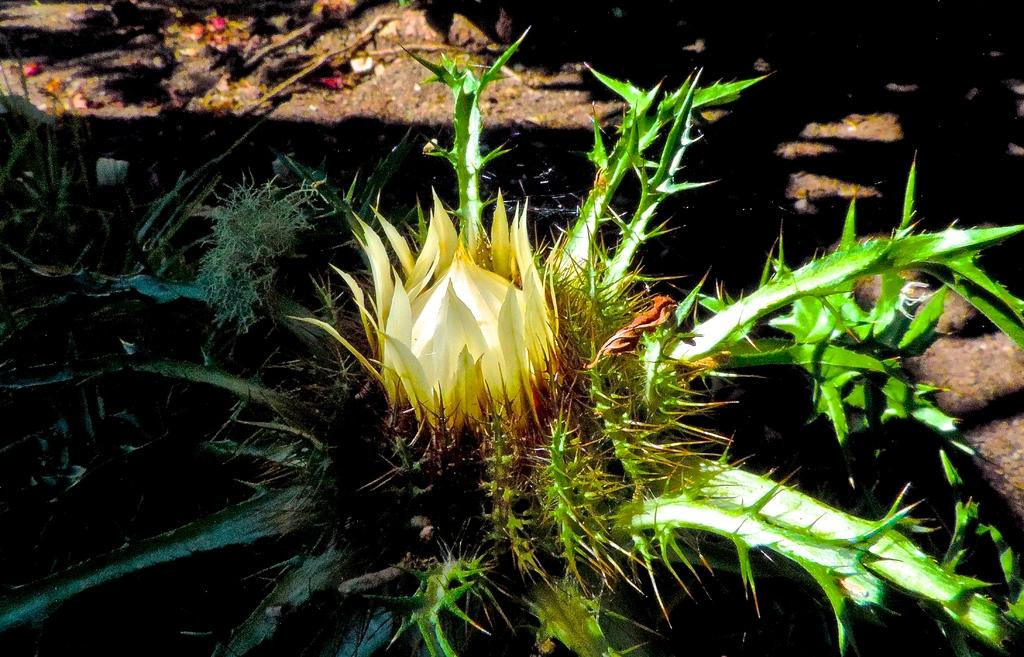What is the main subject in the front of the image? There is a plant in the front of the image. Can you describe the background of the image? The background of the image is blurry. What type of rhythm does the plant have in the image? The plant does not have a rhythm in the image; it is a static object. 